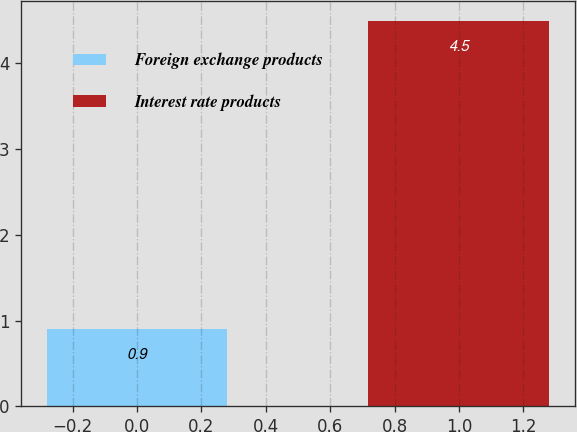Convert chart. <chart><loc_0><loc_0><loc_500><loc_500><bar_chart><fcel>Foreign exchange products<fcel>Interest rate products<nl><fcel>0.9<fcel>4.5<nl></chart> 